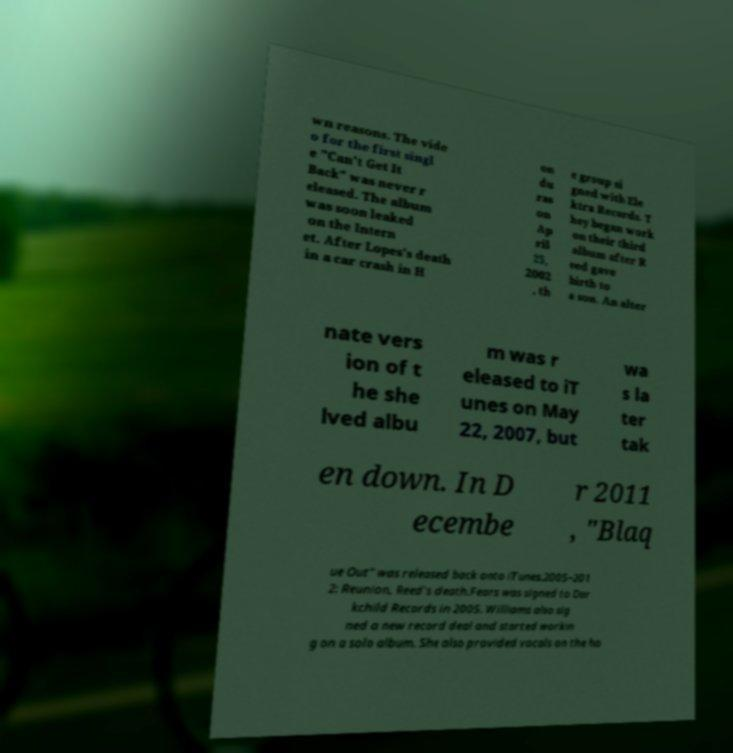Could you assist in decoding the text presented in this image and type it out clearly? wn reasons. The vide o for the first singl e "Can't Get It Back" was never r eleased. The album was soon leaked on the Intern et. After Lopes's death in a car crash in H on du ras on Ap ril 25, 2002 , th e group si gned with Ele ktra Records. T hey began work on their third album after R eed gave birth to a son. An alter nate vers ion of t he she lved albu m was r eleased to iT unes on May 22, 2007, but wa s la ter tak en down. In D ecembe r 2011 , "Blaq ue Out" was released back onto iTunes.2005–201 2: Reunion, Reed's death.Fears was signed to Dar kchild Records in 2005. Williams also sig ned a new record deal and started workin g on a solo album. She also provided vocals on the ho 